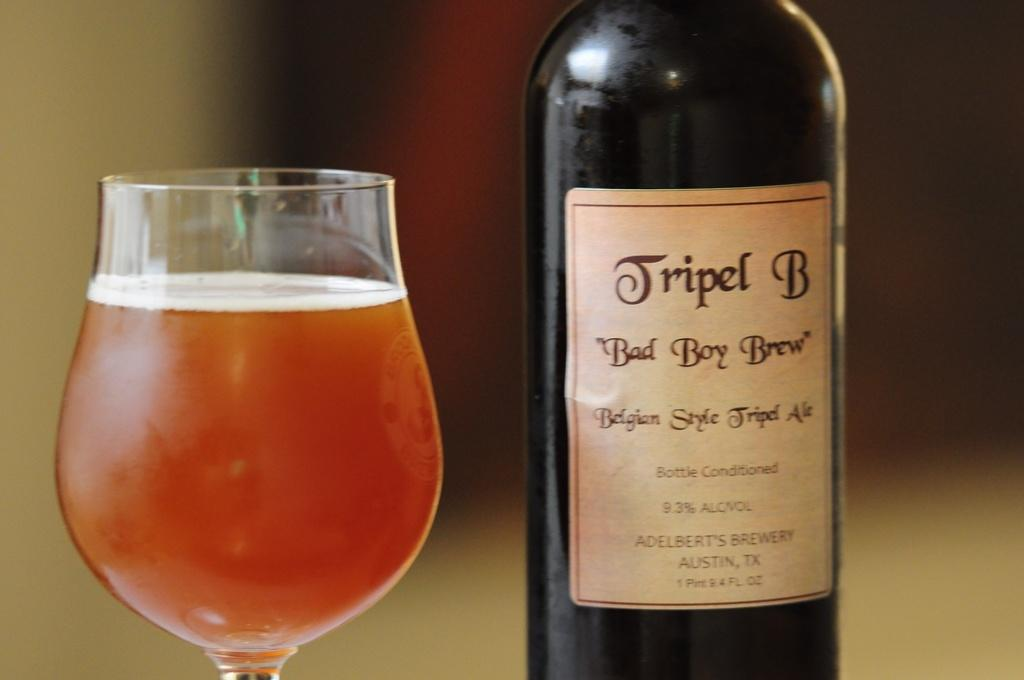<image>
Create a compact narrative representing the image presented. Tripel B Bad Boy Brew contains 9.3% ALC/VOL 